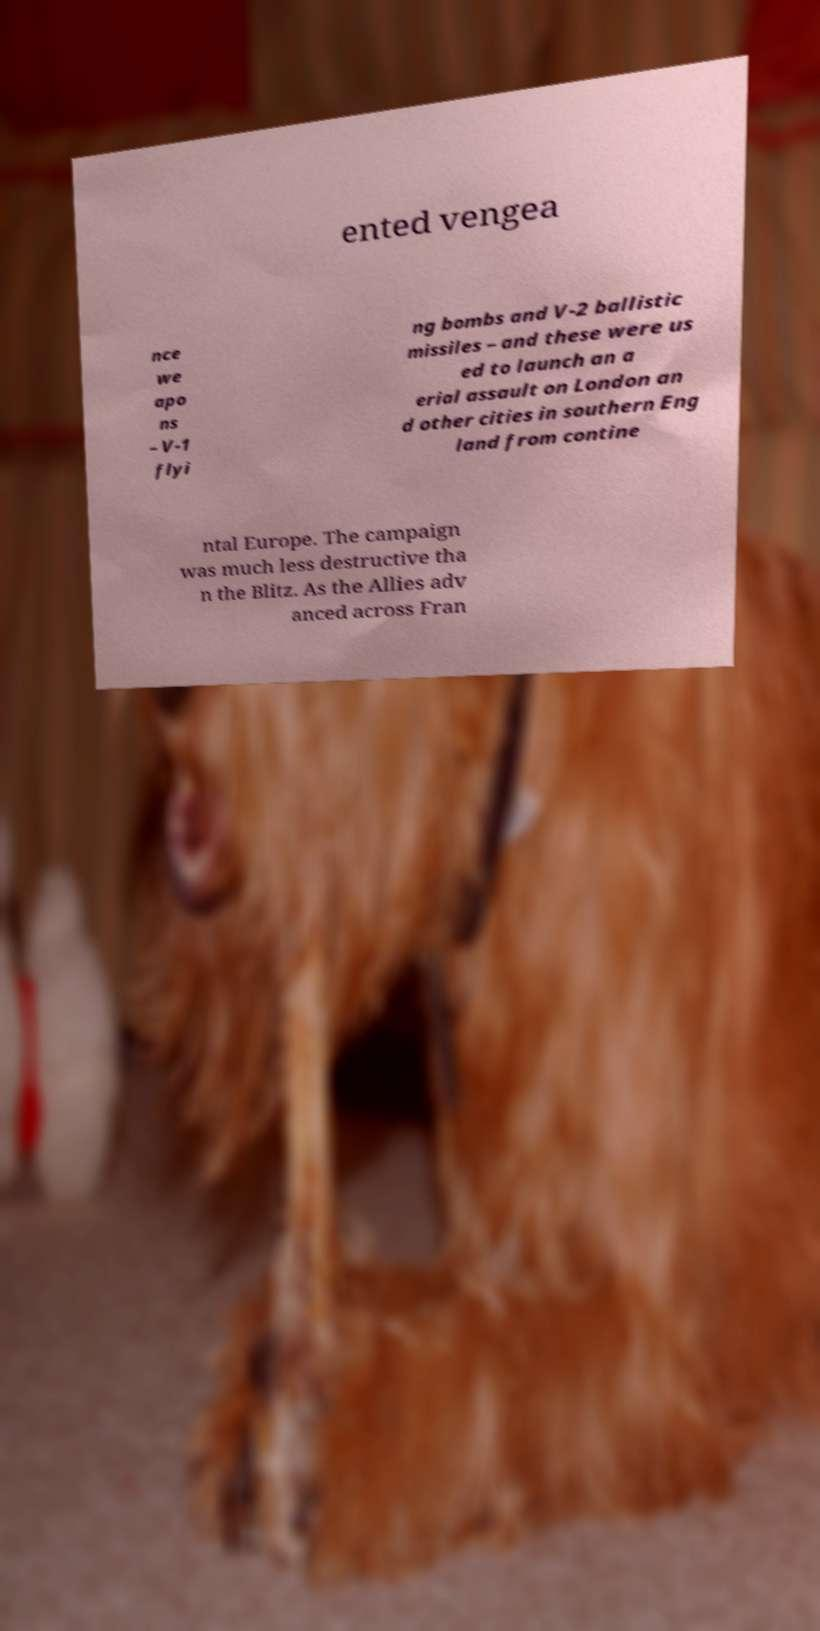There's text embedded in this image that I need extracted. Can you transcribe it verbatim? ented vengea nce we apo ns – V-1 flyi ng bombs and V-2 ballistic missiles – and these were us ed to launch an a erial assault on London an d other cities in southern Eng land from contine ntal Europe. The campaign was much less destructive tha n the Blitz. As the Allies adv anced across Fran 